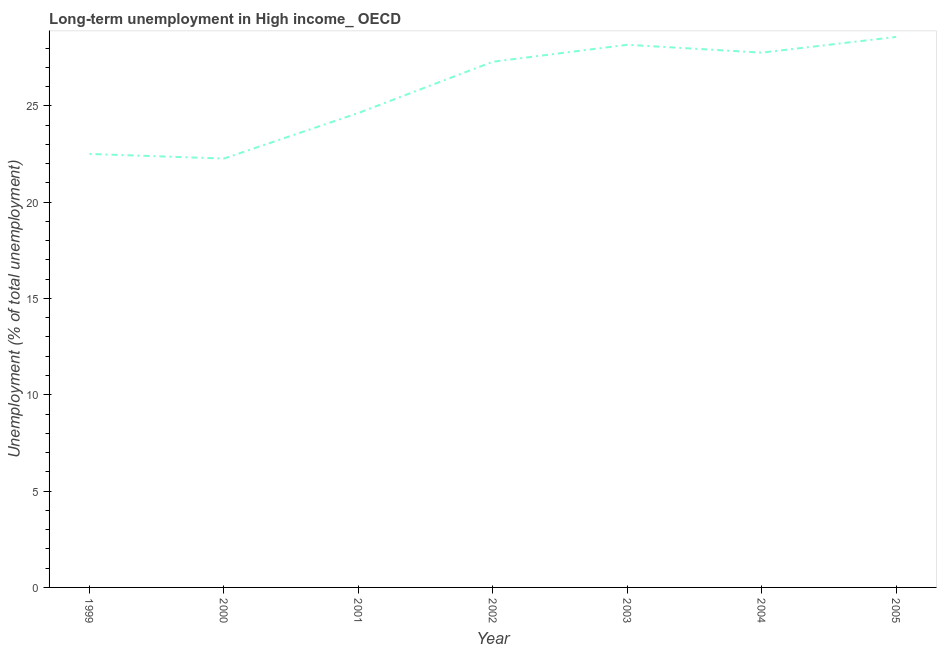What is the long-term unemployment in 2001?
Keep it short and to the point. 24.63. Across all years, what is the maximum long-term unemployment?
Your response must be concise. 28.58. Across all years, what is the minimum long-term unemployment?
Your answer should be very brief. 22.26. In which year was the long-term unemployment minimum?
Give a very brief answer. 2000. What is the sum of the long-term unemployment?
Provide a short and direct response. 181.19. What is the difference between the long-term unemployment in 2000 and 2004?
Ensure brevity in your answer.  -5.5. What is the average long-term unemployment per year?
Your answer should be compact. 25.88. What is the median long-term unemployment?
Your answer should be very brief. 27.29. In how many years, is the long-term unemployment greater than 18 %?
Your response must be concise. 7. Do a majority of the years between 2004 and 2003 (inclusive) have long-term unemployment greater than 17 %?
Offer a terse response. No. What is the ratio of the long-term unemployment in 1999 to that in 2003?
Keep it short and to the point. 0.8. Is the difference between the long-term unemployment in 2000 and 2001 greater than the difference between any two years?
Your answer should be compact. No. What is the difference between the highest and the second highest long-term unemployment?
Provide a succinct answer. 0.41. What is the difference between the highest and the lowest long-term unemployment?
Your response must be concise. 6.32. In how many years, is the long-term unemployment greater than the average long-term unemployment taken over all years?
Provide a short and direct response. 4. How many lines are there?
Your response must be concise. 1. How many years are there in the graph?
Offer a terse response. 7. Does the graph contain grids?
Offer a terse response. No. What is the title of the graph?
Offer a very short reply. Long-term unemployment in High income_ OECD. What is the label or title of the Y-axis?
Make the answer very short. Unemployment (% of total unemployment). What is the Unemployment (% of total unemployment) in 1999?
Give a very brief answer. 22.5. What is the Unemployment (% of total unemployment) of 2000?
Keep it short and to the point. 22.26. What is the Unemployment (% of total unemployment) in 2001?
Your response must be concise. 24.63. What is the Unemployment (% of total unemployment) of 2002?
Provide a succinct answer. 27.29. What is the Unemployment (% of total unemployment) of 2003?
Ensure brevity in your answer.  28.17. What is the Unemployment (% of total unemployment) in 2004?
Your response must be concise. 27.76. What is the Unemployment (% of total unemployment) of 2005?
Offer a terse response. 28.58. What is the difference between the Unemployment (% of total unemployment) in 1999 and 2000?
Keep it short and to the point. 0.24. What is the difference between the Unemployment (% of total unemployment) in 1999 and 2001?
Your answer should be very brief. -2.13. What is the difference between the Unemployment (% of total unemployment) in 1999 and 2002?
Your answer should be compact. -4.79. What is the difference between the Unemployment (% of total unemployment) in 1999 and 2003?
Provide a short and direct response. -5.67. What is the difference between the Unemployment (% of total unemployment) in 1999 and 2004?
Your response must be concise. -5.26. What is the difference between the Unemployment (% of total unemployment) in 1999 and 2005?
Offer a very short reply. -6.07. What is the difference between the Unemployment (% of total unemployment) in 2000 and 2001?
Your answer should be compact. -2.37. What is the difference between the Unemployment (% of total unemployment) in 2000 and 2002?
Give a very brief answer. -5.03. What is the difference between the Unemployment (% of total unemployment) in 2000 and 2003?
Provide a short and direct response. -5.91. What is the difference between the Unemployment (% of total unemployment) in 2000 and 2004?
Keep it short and to the point. -5.5. What is the difference between the Unemployment (% of total unemployment) in 2000 and 2005?
Provide a succinct answer. -6.32. What is the difference between the Unemployment (% of total unemployment) in 2001 and 2002?
Your answer should be compact. -2.66. What is the difference between the Unemployment (% of total unemployment) in 2001 and 2003?
Make the answer very short. -3.54. What is the difference between the Unemployment (% of total unemployment) in 2001 and 2004?
Ensure brevity in your answer.  -3.13. What is the difference between the Unemployment (% of total unemployment) in 2001 and 2005?
Your answer should be very brief. -3.95. What is the difference between the Unemployment (% of total unemployment) in 2002 and 2003?
Your answer should be very brief. -0.88. What is the difference between the Unemployment (% of total unemployment) in 2002 and 2004?
Your answer should be compact. -0.47. What is the difference between the Unemployment (% of total unemployment) in 2002 and 2005?
Your response must be concise. -1.29. What is the difference between the Unemployment (% of total unemployment) in 2003 and 2004?
Offer a very short reply. 0.41. What is the difference between the Unemployment (% of total unemployment) in 2003 and 2005?
Give a very brief answer. -0.41. What is the difference between the Unemployment (% of total unemployment) in 2004 and 2005?
Provide a short and direct response. -0.82. What is the ratio of the Unemployment (% of total unemployment) in 1999 to that in 2001?
Ensure brevity in your answer.  0.91. What is the ratio of the Unemployment (% of total unemployment) in 1999 to that in 2002?
Your answer should be very brief. 0.82. What is the ratio of the Unemployment (% of total unemployment) in 1999 to that in 2003?
Keep it short and to the point. 0.8. What is the ratio of the Unemployment (% of total unemployment) in 1999 to that in 2004?
Provide a short and direct response. 0.81. What is the ratio of the Unemployment (% of total unemployment) in 1999 to that in 2005?
Keep it short and to the point. 0.79. What is the ratio of the Unemployment (% of total unemployment) in 2000 to that in 2001?
Your answer should be compact. 0.9. What is the ratio of the Unemployment (% of total unemployment) in 2000 to that in 2002?
Provide a succinct answer. 0.82. What is the ratio of the Unemployment (% of total unemployment) in 2000 to that in 2003?
Your answer should be very brief. 0.79. What is the ratio of the Unemployment (% of total unemployment) in 2000 to that in 2004?
Your answer should be compact. 0.8. What is the ratio of the Unemployment (% of total unemployment) in 2000 to that in 2005?
Offer a very short reply. 0.78. What is the ratio of the Unemployment (% of total unemployment) in 2001 to that in 2002?
Your answer should be very brief. 0.9. What is the ratio of the Unemployment (% of total unemployment) in 2001 to that in 2003?
Give a very brief answer. 0.87. What is the ratio of the Unemployment (% of total unemployment) in 2001 to that in 2004?
Give a very brief answer. 0.89. What is the ratio of the Unemployment (% of total unemployment) in 2001 to that in 2005?
Provide a short and direct response. 0.86. What is the ratio of the Unemployment (% of total unemployment) in 2002 to that in 2003?
Your answer should be very brief. 0.97. What is the ratio of the Unemployment (% of total unemployment) in 2002 to that in 2004?
Offer a terse response. 0.98. What is the ratio of the Unemployment (% of total unemployment) in 2002 to that in 2005?
Provide a short and direct response. 0.95. What is the ratio of the Unemployment (% of total unemployment) in 2003 to that in 2004?
Make the answer very short. 1.01. 